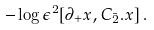Convert formula to latex. <formula><loc_0><loc_0><loc_500><loc_500>- \log \epsilon ^ { 2 } [ \partial _ { + } x , C _ { \bar { 2 } } . x ] \, .</formula> 